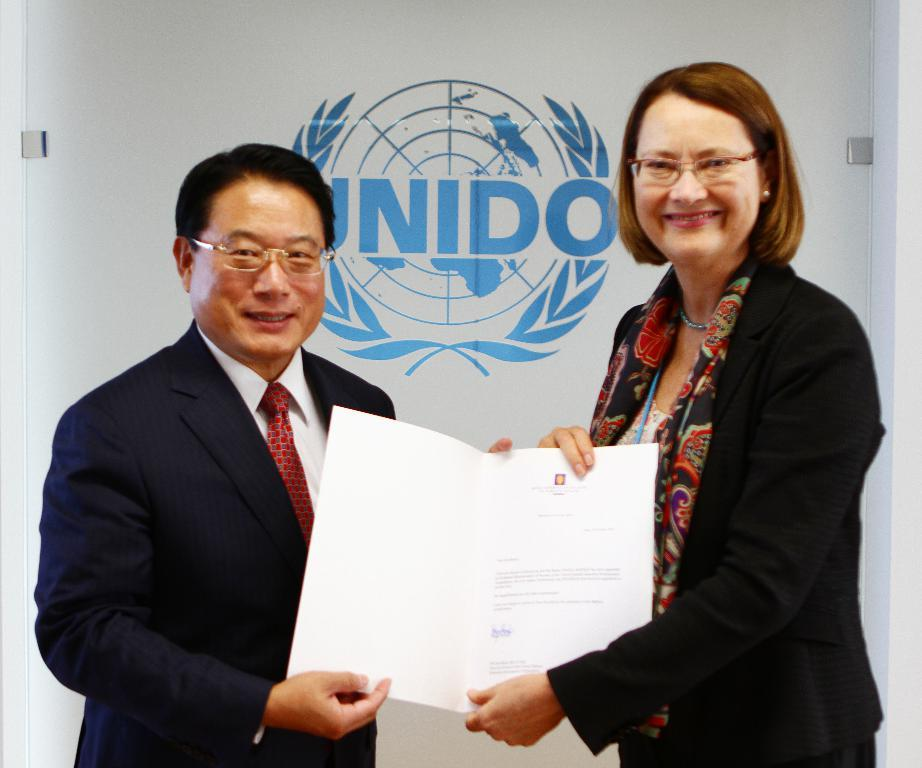How many people are in the image? There are two people in the image, a woman and a man. What are the people in the image doing? The woman and the man are standing and smiling. What are they holding in the image? They are holding a paper. What can be seen on the wall in the background of the image? There is a banner on the wall in the background. What is written on the banner? The banner has text on it. What else is on the banner? The banner has a logo on it. What type of twig is the woman holding in the image? There is no twig present in the image; the woman and the man are holding a paper. 